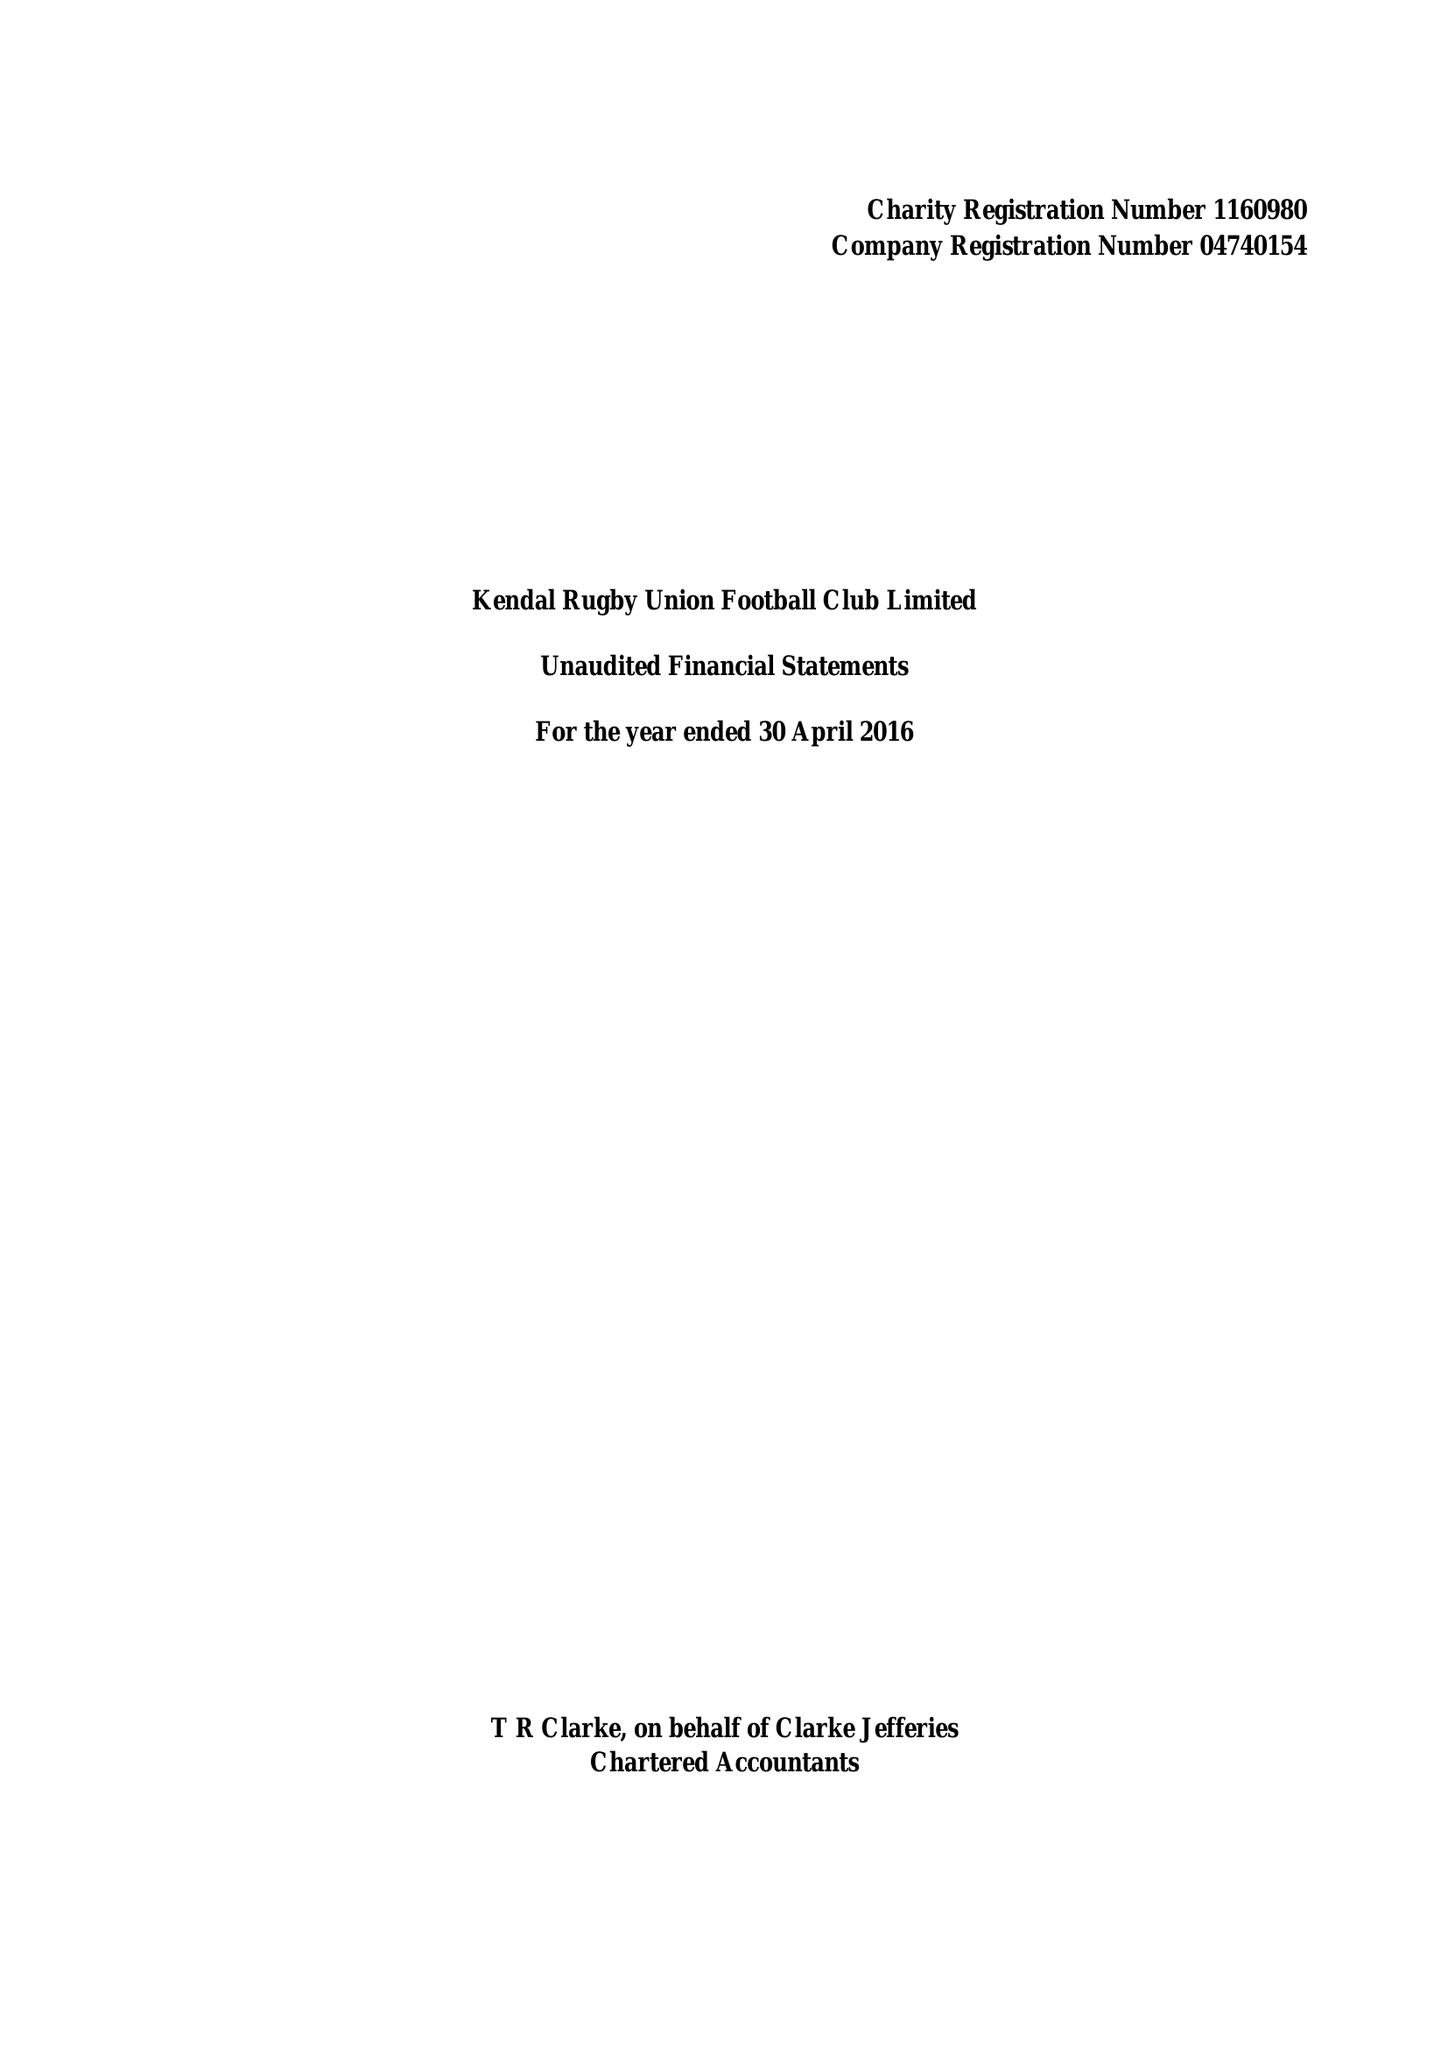What is the value for the charity_number?
Answer the question using a single word or phrase. 1160980 